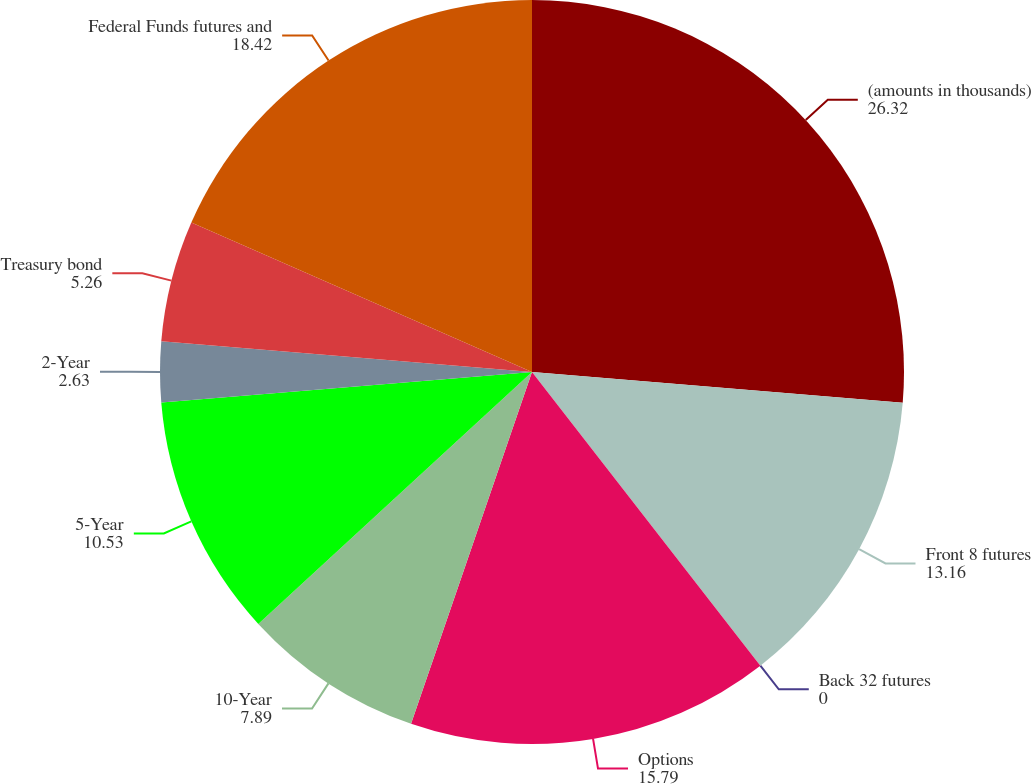<chart> <loc_0><loc_0><loc_500><loc_500><pie_chart><fcel>(amounts in thousands)<fcel>Front 8 futures<fcel>Back 32 futures<fcel>Options<fcel>10-Year<fcel>5-Year<fcel>2-Year<fcel>Treasury bond<fcel>Federal Funds futures and<nl><fcel>26.32%<fcel>13.16%<fcel>0.0%<fcel>15.79%<fcel>7.89%<fcel>10.53%<fcel>2.63%<fcel>5.26%<fcel>18.42%<nl></chart> 